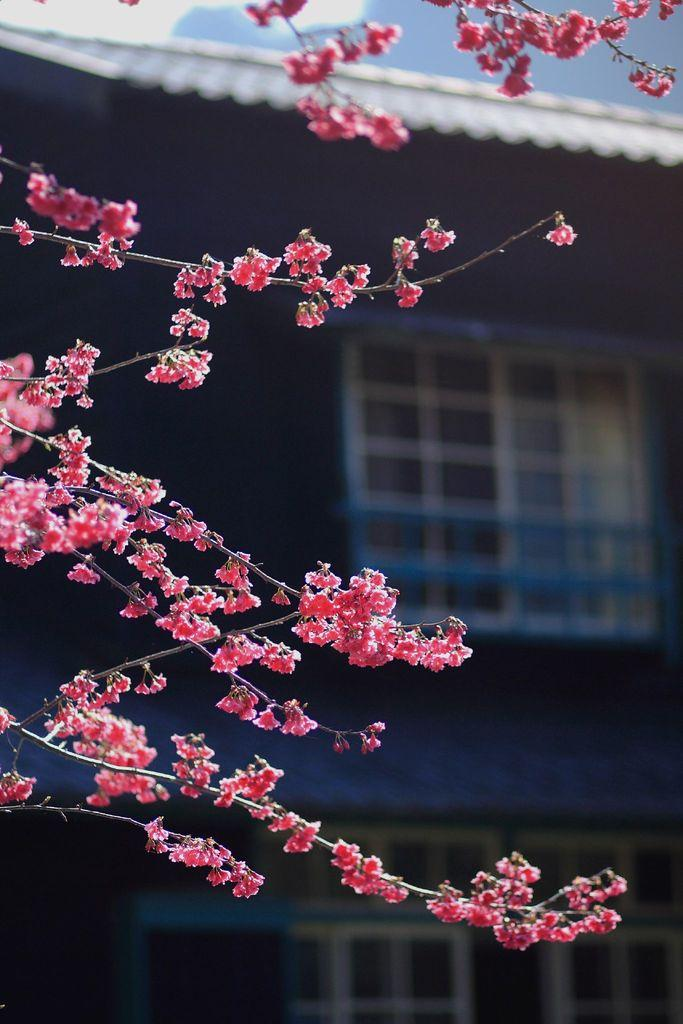What type of plants can be seen in the image? There are flowers in the image. How are the flowers arranged or connected? The flowers are on stems. What color are the flowers in the image? The flowers are pink in color. What can be seen in the background of the image? There is a building in the background of the image. What architectural feature is visible in the building? There are windows visible in the building. What type of lead can be seen connecting the flowers in the image? There is no lead connecting the flowers in the image; they are on stems. 